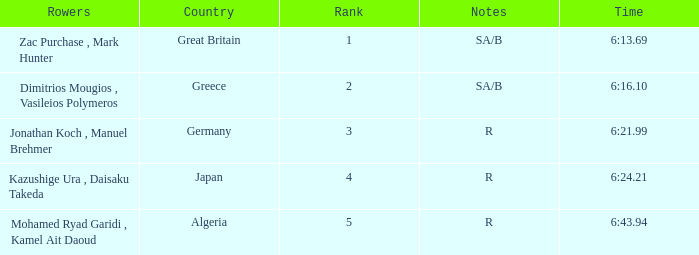What country is ranked #2? Greece. 